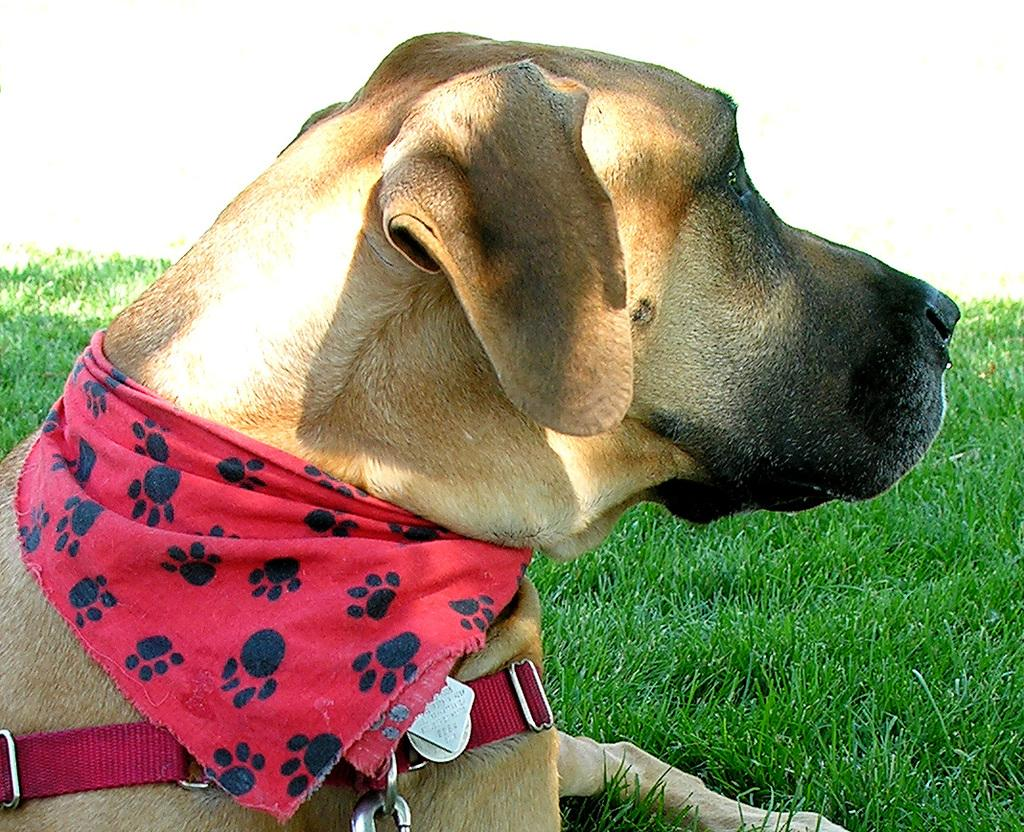What type of animal is in the picture? There is a dog in the picture. What accessories does the dog have? The dog has a red belt and a red scarf around its neck. Where is the dog sitting? The dog is sitting on green grass. In which direction is the dog looking? The dog is looking in a particular direction. How many women are sitting on the chair in the image? There are no women or chairs present in the image; it features a dog with accessories sitting on green grass. 